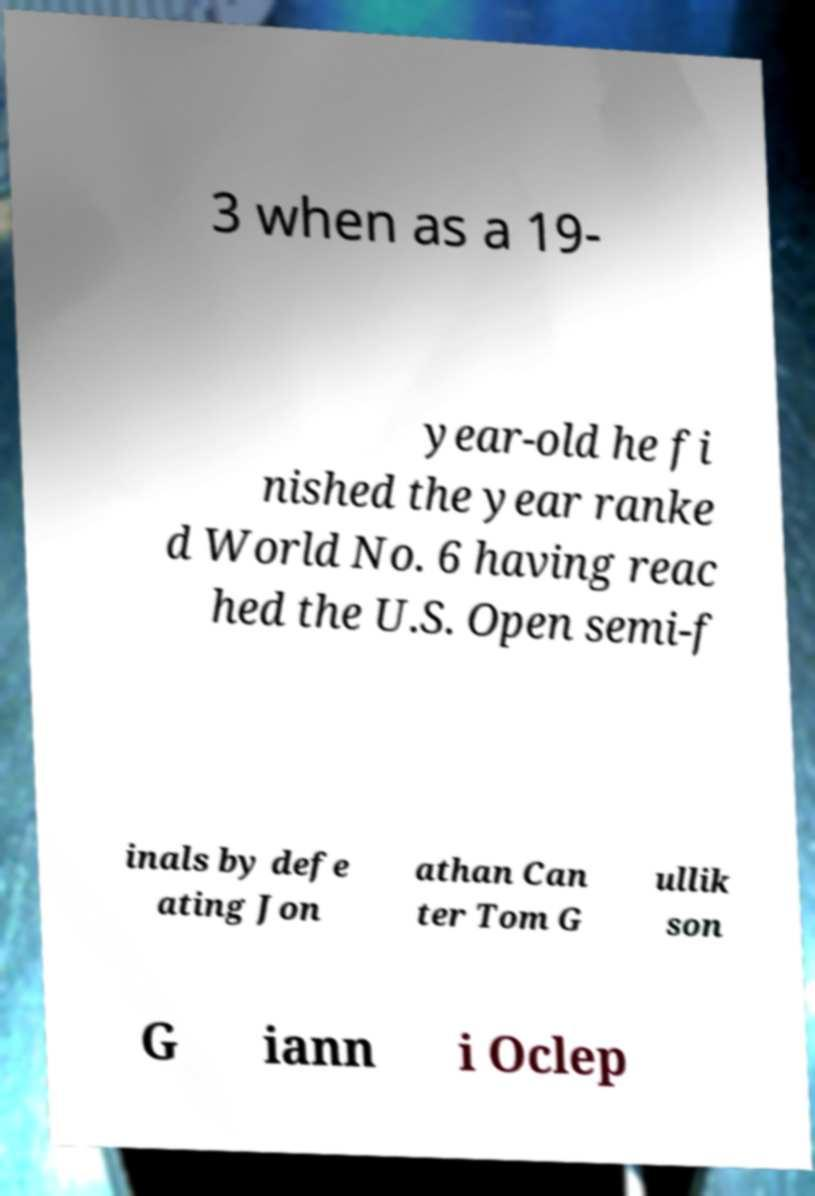Could you extract and type out the text from this image? 3 when as a 19- year-old he fi nished the year ranke d World No. 6 having reac hed the U.S. Open semi-f inals by defe ating Jon athan Can ter Tom G ullik son G iann i Oclep 